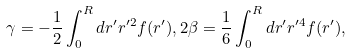Convert formula to latex. <formula><loc_0><loc_0><loc_500><loc_500>\gamma = - \frac { 1 } { 2 } \int _ { 0 } ^ { R } d r ^ { \prime } r ^ { \prime 2 } f ( r ^ { \prime } ) , 2 \beta = \frac { 1 } { 6 } \int _ { 0 } ^ { R } d r ^ { \prime } r ^ { \prime 4 } f ( r ^ { \prime } ) ,</formula> 